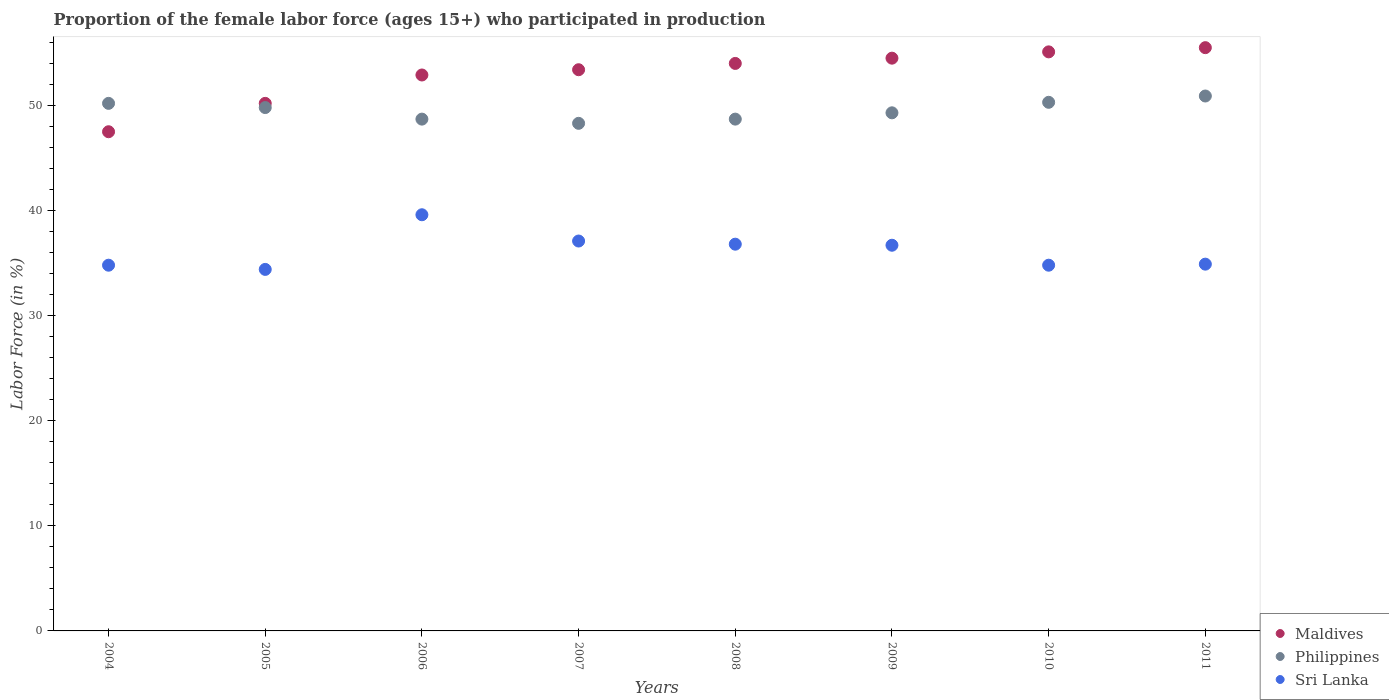How many different coloured dotlines are there?
Provide a short and direct response. 3. What is the proportion of the female labor force who participated in production in Maldives in 2010?
Keep it short and to the point. 55.1. Across all years, what is the maximum proportion of the female labor force who participated in production in Maldives?
Provide a short and direct response. 55.5. Across all years, what is the minimum proportion of the female labor force who participated in production in Maldives?
Provide a succinct answer. 47.5. What is the total proportion of the female labor force who participated in production in Philippines in the graph?
Your response must be concise. 396.2. What is the difference between the proportion of the female labor force who participated in production in Philippines in 2009 and that in 2011?
Offer a terse response. -1.6. What is the difference between the proportion of the female labor force who participated in production in Maldives in 2004 and the proportion of the female labor force who participated in production in Philippines in 2011?
Provide a short and direct response. -3.4. What is the average proportion of the female labor force who participated in production in Sri Lanka per year?
Offer a very short reply. 36.14. In the year 2006, what is the difference between the proportion of the female labor force who participated in production in Sri Lanka and proportion of the female labor force who participated in production in Philippines?
Offer a very short reply. -9.1. In how many years, is the proportion of the female labor force who participated in production in Maldives greater than 24 %?
Provide a short and direct response. 8. What is the ratio of the proportion of the female labor force who participated in production in Philippines in 2004 to that in 2007?
Ensure brevity in your answer.  1.04. Is the proportion of the female labor force who participated in production in Philippines in 2009 less than that in 2011?
Give a very brief answer. Yes. What is the difference between the highest and the second highest proportion of the female labor force who participated in production in Philippines?
Your answer should be very brief. 0.6. What is the difference between the highest and the lowest proportion of the female labor force who participated in production in Maldives?
Ensure brevity in your answer.  8. Is it the case that in every year, the sum of the proportion of the female labor force who participated in production in Philippines and proportion of the female labor force who participated in production in Maldives  is greater than the proportion of the female labor force who participated in production in Sri Lanka?
Make the answer very short. Yes. Does the proportion of the female labor force who participated in production in Philippines monotonically increase over the years?
Provide a short and direct response. No. How many years are there in the graph?
Provide a succinct answer. 8. Are the values on the major ticks of Y-axis written in scientific E-notation?
Provide a short and direct response. No. Does the graph contain any zero values?
Provide a short and direct response. No. How many legend labels are there?
Provide a succinct answer. 3. How are the legend labels stacked?
Give a very brief answer. Vertical. What is the title of the graph?
Give a very brief answer. Proportion of the female labor force (ages 15+) who participated in production. What is the Labor Force (in %) in Maldives in 2004?
Keep it short and to the point. 47.5. What is the Labor Force (in %) in Philippines in 2004?
Offer a very short reply. 50.2. What is the Labor Force (in %) of Sri Lanka in 2004?
Your answer should be compact. 34.8. What is the Labor Force (in %) in Maldives in 2005?
Your response must be concise. 50.2. What is the Labor Force (in %) of Philippines in 2005?
Make the answer very short. 49.8. What is the Labor Force (in %) of Sri Lanka in 2005?
Offer a very short reply. 34.4. What is the Labor Force (in %) of Maldives in 2006?
Keep it short and to the point. 52.9. What is the Labor Force (in %) in Philippines in 2006?
Keep it short and to the point. 48.7. What is the Labor Force (in %) in Sri Lanka in 2006?
Your answer should be compact. 39.6. What is the Labor Force (in %) of Maldives in 2007?
Your answer should be compact. 53.4. What is the Labor Force (in %) in Philippines in 2007?
Your response must be concise. 48.3. What is the Labor Force (in %) of Sri Lanka in 2007?
Your answer should be very brief. 37.1. What is the Labor Force (in %) of Maldives in 2008?
Your answer should be compact. 54. What is the Labor Force (in %) in Philippines in 2008?
Ensure brevity in your answer.  48.7. What is the Labor Force (in %) of Sri Lanka in 2008?
Offer a terse response. 36.8. What is the Labor Force (in %) in Maldives in 2009?
Make the answer very short. 54.5. What is the Labor Force (in %) of Philippines in 2009?
Provide a short and direct response. 49.3. What is the Labor Force (in %) in Sri Lanka in 2009?
Offer a very short reply. 36.7. What is the Labor Force (in %) of Maldives in 2010?
Give a very brief answer. 55.1. What is the Labor Force (in %) of Philippines in 2010?
Provide a short and direct response. 50.3. What is the Labor Force (in %) in Sri Lanka in 2010?
Your answer should be compact. 34.8. What is the Labor Force (in %) in Maldives in 2011?
Offer a very short reply. 55.5. What is the Labor Force (in %) of Philippines in 2011?
Make the answer very short. 50.9. What is the Labor Force (in %) of Sri Lanka in 2011?
Keep it short and to the point. 34.9. Across all years, what is the maximum Labor Force (in %) of Maldives?
Your answer should be compact. 55.5. Across all years, what is the maximum Labor Force (in %) in Philippines?
Give a very brief answer. 50.9. Across all years, what is the maximum Labor Force (in %) in Sri Lanka?
Your response must be concise. 39.6. Across all years, what is the minimum Labor Force (in %) in Maldives?
Keep it short and to the point. 47.5. Across all years, what is the minimum Labor Force (in %) in Philippines?
Your response must be concise. 48.3. Across all years, what is the minimum Labor Force (in %) in Sri Lanka?
Offer a terse response. 34.4. What is the total Labor Force (in %) in Maldives in the graph?
Keep it short and to the point. 423.1. What is the total Labor Force (in %) of Philippines in the graph?
Make the answer very short. 396.2. What is the total Labor Force (in %) of Sri Lanka in the graph?
Provide a short and direct response. 289.1. What is the difference between the Labor Force (in %) of Maldives in 2004 and that in 2005?
Give a very brief answer. -2.7. What is the difference between the Labor Force (in %) of Sri Lanka in 2004 and that in 2005?
Offer a terse response. 0.4. What is the difference between the Labor Force (in %) in Sri Lanka in 2004 and that in 2007?
Make the answer very short. -2.3. What is the difference between the Labor Force (in %) in Maldives in 2004 and that in 2008?
Provide a succinct answer. -6.5. What is the difference between the Labor Force (in %) in Philippines in 2004 and that in 2009?
Keep it short and to the point. 0.9. What is the difference between the Labor Force (in %) of Maldives in 2004 and that in 2010?
Your answer should be very brief. -7.6. What is the difference between the Labor Force (in %) in Philippines in 2004 and that in 2010?
Offer a terse response. -0.1. What is the difference between the Labor Force (in %) in Maldives in 2004 and that in 2011?
Keep it short and to the point. -8. What is the difference between the Labor Force (in %) of Philippines in 2004 and that in 2011?
Ensure brevity in your answer.  -0.7. What is the difference between the Labor Force (in %) in Sri Lanka in 2004 and that in 2011?
Make the answer very short. -0.1. What is the difference between the Labor Force (in %) in Sri Lanka in 2005 and that in 2006?
Ensure brevity in your answer.  -5.2. What is the difference between the Labor Force (in %) in Maldives in 2005 and that in 2007?
Provide a succinct answer. -3.2. What is the difference between the Labor Force (in %) in Philippines in 2005 and that in 2007?
Offer a very short reply. 1.5. What is the difference between the Labor Force (in %) of Philippines in 2005 and that in 2008?
Offer a terse response. 1.1. What is the difference between the Labor Force (in %) in Maldives in 2005 and that in 2009?
Offer a terse response. -4.3. What is the difference between the Labor Force (in %) in Maldives in 2005 and that in 2010?
Provide a short and direct response. -4.9. What is the difference between the Labor Force (in %) in Philippines in 2005 and that in 2010?
Offer a very short reply. -0.5. What is the difference between the Labor Force (in %) of Sri Lanka in 2005 and that in 2010?
Provide a short and direct response. -0.4. What is the difference between the Labor Force (in %) of Maldives in 2005 and that in 2011?
Offer a terse response. -5.3. What is the difference between the Labor Force (in %) in Sri Lanka in 2005 and that in 2011?
Offer a terse response. -0.5. What is the difference between the Labor Force (in %) of Maldives in 2006 and that in 2007?
Give a very brief answer. -0.5. What is the difference between the Labor Force (in %) of Sri Lanka in 2006 and that in 2007?
Keep it short and to the point. 2.5. What is the difference between the Labor Force (in %) in Maldives in 2006 and that in 2009?
Make the answer very short. -1.6. What is the difference between the Labor Force (in %) of Sri Lanka in 2006 and that in 2009?
Your response must be concise. 2.9. What is the difference between the Labor Force (in %) of Maldives in 2006 and that in 2010?
Ensure brevity in your answer.  -2.2. What is the difference between the Labor Force (in %) in Maldives in 2006 and that in 2011?
Provide a short and direct response. -2.6. What is the difference between the Labor Force (in %) in Sri Lanka in 2006 and that in 2011?
Offer a very short reply. 4.7. What is the difference between the Labor Force (in %) of Philippines in 2007 and that in 2008?
Your answer should be compact. -0.4. What is the difference between the Labor Force (in %) of Philippines in 2007 and that in 2009?
Your answer should be very brief. -1. What is the difference between the Labor Force (in %) in Philippines in 2007 and that in 2010?
Your answer should be compact. -2. What is the difference between the Labor Force (in %) in Sri Lanka in 2007 and that in 2010?
Ensure brevity in your answer.  2.3. What is the difference between the Labor Force (in %) in Maldives in 2007 and that in 2011?
Provide a short and direct response. -2.1. What is the difference between the Labor Force (in %) of Philippines in 2007 and that in 2011?
Keep it short and to the point. -2.6. What is the difference between the Labor Force (in %) in Maldives in 2008 and that in 2010?
Your answer should be very brief. -1.1. What is the difference between the Labor Force (in %) of Philippines in 2008 and that in 2010?
Offer a very short reply. -1.6. What is the difference between the Labor Force (in %) of Sri Lanka in 2008 and that in 2010?
Ensure brevity in your answer.  2. What is the difference between the Labor Force (in %) of Maldives in 2009 and that in 2010?
Provide a short and direct response. -0.6. What is the difference between the Labor Force (in %) in Philippines in 2009 and that in 2010?
Offer a very short reply. -1. What is the difference between the Labor Force (in %) in Sri Lanka in 2009 and that in 2010?
Make the answer very short. 1.9. What is the difference between the Labor Force (in %) of Philippines in 2009 and that in 2011?
Ensure brevity in your answer.  -1.6. What is the difference between the Labor Force (in %) of Sri Lanka in 2009 and that in 2011?
Make the answer very short. 1.8. What is the difference between the Labor Force (in %) in Philippines in 2010 and that in 2011?
Provide a short and direct response. -0.6. What is the difference between the Labor Force (in %) of Sri Lanka in 2010 and that in 2011?
Offer a very short reply. -0.1. What is the difference between the Labor Force (in %) in Maldives in 2004 and the Labor Force (in %) in Sri Lanka in 2005?
Keep it short and to the point. 13.1. What is the difference between the Labor Force (in %) in Philippines in 2004 and the Labor Force (in %) in Sri Lanka in 2005?
Keep it short and to the point. 15.8. What is the difference between the Labor Force (in %) in Maldives in 2004 and the Labor Force (in %) in Philippines in 2006?
Provide a short and direct response. -1.2. What is the difference between the Labor Force (in %) of Maldives in 2004 and the Labor Force (in %) of Sri Lanka in 2006?
Give a very brief answer. 7.9. What is the difference between the Labor Force (in %) of Philippines in 2004 and the Labor Force (in %) of Sri Lanka in 2006?
Keep it short and to the point. 10.6. What is the difference between the Labor Force (in %) in Maldives in 2004 and the Labor Force (in %) in Philippines in 2007?
Ensure brevity in your answer.  -0.8. What is the difference between the Labor Force (in %) of Maldives in 2004 and the Labor Force (in %) of Sri Lanka in 2007?
Your response must be concise. 10.4. What is the difference between the Labor Force (in %) of Maldives in 2004 and the Labor Force (in %) of Philippines in 2008?
Provide a succinct answer. -1.2. What is the difference between the Labor Force (in %) of Maldives in 2004 and the Labor Force (in %) of Philippines in 2009?
Offer a terse response. -1.8. What is the difference between the Labor Force (in %) in Maldives in 2004 and the Labor Force (in %) in Sri Lanka in 2009?
Offer a terse response. 10.8. What is the difference between the Labor Force (in %) in Philippines in 2004 and the Labor Force (in %) in Sri Lanka in 2009?
Ensure brevity in your answer.  13.5. What is the difference between the Labor Force (in %) of Philippines in 2004 and the Labor Force (in %) of Sri Lanka in 2010?
Your answer should be very brief. 15.4. What is the difference between the Labor Force (in %) in Maldives in 2004 and the Labor Force (in %) in Philippines in 2011?
Provide a succinct answer. -3.4. What is the difference between the Labor Force (in %) in Maldives in 2004 and the Labor Force (in %) in Sri Lanka in 2011?
Provide a succinct answer. 12.6. What is the difference between the Labor Force (in %) in Philippines in 2004 and the Labor Force (in %) in Sri Lanka in 2011?
Your answer should be compact. 15.3. What is the difference between the Labor Force (in %) in Philippines in 2005 and the Labor Force (in %) in Sri Lanka in 2006?
Provide a succinct answer. 10.2. What is the difference between the Labor Force (in %) of Maldives in 2005 and the Labor Force (in %) of Philippines in 2008?
Offer a terse response. 1.5. What is the difference between the Labor Force (in %) of Philippines in 2005 and the Labor Force (in %) of Sri Lanka in 2009?
Offer a very short reply. 13.1. What is the difference between the Labor Force (in %) of Maldives in 2005 and the Labor Force (in %) of Philippines in 2010?
Provide a short and direct response. -0.1. What is the difference between the Labor Force (in %) of Philippines in 2005 and the Labor Force (in %) of Sri Lanka in 2010?
Your answer should be compact. 15. What is the difference between the Labor Force (in %) of Maldives in 2005 and the Labor Force (in %) of Philippines in 2011?
Give a very brief answer. -0.7. What is the difference between the Labor Force (in %) of Maldives in 2005 and the Labor Force (in %) of Sri Lanka in 2011?
Keep it short and to the point. 15.3. What is the difference between the Labor Force (in %) in Maldives in 2006 and the Labor Force (in %) in Philippines in 2007?
Your answer should be compact. 4.6. What is the difference between the Labor Force (in %) of Maldives in 2006 and the Labor Force (in %) of Sri Lanka in 2007?
Offer a terse response. 15.8. What is the difference between the Labor Force (in %) in Philippines in 2006 and the Labor Force (in %) in Sri Lanka in 2007?
Offer a very short reply. 11.6. What is the difference between the Labor Force (in %) in Maldives in 2006 and the Labor Force (in %) in Sri Lanka in 2008?
Keep it short and to the point. 16.1. What is the difference between the Labor Force (in %) of Maldives in 2006 and the Labor Force (in %) of Philippines in 2009?
Provide a short and direct response. 3.6. What is the difference between the Labor Force (in %) in Maldives in 2006 and the Labor Force (in %) in Philippines in 2011?
Your answer should be very brief. 2. What is the difference between the Labor Force (in %) of Maldives in 2007 and the Labor Force (in %) of Philippines in 2008?
Your response must be concise. 4.7. What is the difference between the Labor Force (in %) of Philippines in 2007 and the Labor Force (in %) of Sri Lanka in 2008?
Keep it short and to the point. 11.5. What is the difference between the Labor Force (in %) in Philippines in 2007 and the Labor Force (in %) in Sri Lanka in 2009?
Ensure brevity in your answer.  11.6. What is the difference between the Labor Force (in %) of Maldives in 2007 and the Labor Force (in %) of Sri Lanka in 2010?
Provide a short and direct response. 18.6. What is the difference between the Labor Force (in %) in Maldives in 2007 and the Labor Force (in %) in Philippines in 2011?
Keep it short and to the point. 2.5. What is the difference between the Labor Force (in %) of Maldives in 2007 and the Labor Force (in %) of Sri Lanka in 2011?
Offer a very short reply. 18.5. What is the difference between the Labor Force (in %) of Maldives in 2008 and the Labor Force (in %) of Sri Lanka in 2009?
Your response must be concise. 17.3. What is the difference between the Labor Force (in %) in Philippines in 2008 and the Labor Force (in %) in Sri Lanka in 2009?
Offer a terse response. 12. What is the difference between the Labor Force (in %) of Maldives in 2008 and the Labor Force (in %) of Sri Lanka in 2010?
Your answer should be very brief. 19.2. What is the difference between the Labor Force (in %) of Philippines in 2008 and the Labor Force (in %) of Sri Lanka in 2010?
Keep it short and to the point. 13.9. What is the difference between the Labor Force (in %) of Maldives in 2008 and the Labor Force (in %) of Philippines in 2011?
Keep it short and to the point. 3.1. What is the difference between the Labor Force (in %) in Maldives in 2009 and the Labor Force (in %) in Philippines in 2010?
Make the answer very short. 4.2. What is the difference between the Labor Force (in %) in Maldives in 2009 and the Labor Force (in %) in Sri Lanka in 2011?
Ensure brevity in your answer.  19.6. What is the difference between the Labor Force (in %) of Philippines in 2009 and the Labor Force (in %) of Sri Lanka in 2011?
Ensure brevity in your answer.  14.4. What is the difference between the Labor Force (in %) in Maldives in 2010 and the Labor Force (in %) in Philippines in 2011?
Keep it short and to the point. 4.2. What is the difference between the Labor Force (in %) in Maldives in 2010 and the Labor Force (in %) in Sri Lanka in 2011?
Your answer should be compact. 20.2. What is the average Labor Force (in %) of Maldives per year?
Make the answer very short. 52.89. What is the average Labor Force (in %) of Philippines per year?
Offer a terse response. 49.52. What is the average Labor Force (in %) in Sri Lanka per year?
Provide a short and direct response. 36.14. In the year 2004, what is the difference between the Labor Force (in %) of Maldives and Labor Force (in %) of Sri Lanka?
Offer a terse response. 12.7. In the year 2005, what is the difference between the Labor Force (in %) of Maldives and Labor Force (in %) of Philippines?
Provide a short and direct response. 0.4. In the year 2005, what is the difference between the Labor Force (in %) of Philippines and Labor Force (in %) of Sri Lanka?
Your answer should be very brief. 15.4. In the year 2006, what is the difference between the Labor Force (in %) in Maldives and Labor Force (in %) in Philippines?
Offer a terse response. 4.2. In the year 2006, what is the difference between the Labor Force (in %) in Maldives and Labor Force (in %) in Sri Lanka?
Provide a short and direct response. 13.3. In the year 2006, what is the difference between the Labor Force (in %) in Philippines and Labor Force (in %) in Sri Lanka?
Ensure brevity in your answer.  9.1. In the year 2007, what is the difference between the Labor Force (in %) of Maldives and Labor Force (in %) of Philippines?
Provide a short and direct response. 5.1. In the year 2008, what is the difference between the Labor Force (in %) in Maldives and Labor Force (in %) in Philippines?
Give a very brief answer. 5.3. In the year 2008, what is the difference between the Labor Force (in %) of Maldives and Labor Force (in %) of Sri Lanka?
Make the answer very short. 17.2. In the year 2009, what is the difference between the Labor Force (in %) in Maldives and Labor Force (in %) in Philippines?
Keep it short and to the point. 5.2. In the year 2009, what is the difference between the Labor Force (in %) of Maldives and Labor Force (in %) of Sri Lanka?
Provide a short and direct response. 17.8. In the year 2009, what is the difference between the Labor Force (in %) of Philippines and Labor Force (in %) of Sri Lanka?
Keep it short and to the point. 12.6. In the year 2010, what is the difference between the Labor Force (in %) in Maldives and Labor Force (in %) in Sri Lanka?
Your answer should be compact. 20.3. In the year 2011, what is the difference between the Labor Force (in %) of Maldives and Labor Force (in %) of Philippines?
Provide a short and direct response. 4.6. In the year 2011, what is the difference between the Labor Force (in %) of Maldives and Labor Force (in %) of Sri Lanka?
Make the answer very short. 20.6. What is the ratio of the Labor Force (in %) of Maldives in 2004 to that in 2005?
Give a very brief answer. 0.95. What is the ratio of the Labor Force (in %) of Philippines in 2004 to that in 2005?
Offer a very short reply. 1.01. What is the ratio of the Labor Force (in %) of Sri Lanka in 2004 to that in 2005?
Offer a terse response. 1.01. What is the ratio of the Labor Force (in %) in Maldives in 2004 to that in 2006?
Offer a terse response. 0.9. What is the ratio of the Labor Force (in %) in Philippines in 2004 to that in 2006?
Make the answer very short. 1.03. What is the ratio of the Labor Force (in %) of Sri Lanka in 2004 to that in 2006?
Your answer should be compact. 0.88. What is the ratio of the Labor Force (in %) in Maldives in 2004 to that in 2007?
Keep it short and to the point. 0.89. What is the ratio of the Labor Force (in %) of Philippines in 2004 to that in 2007?
Ensure brevity in your answer.  1.04. What is the ratio of the Labor Force (in %) of Sri Lanka in 2004 to that in 2007?
Keep it short and to the point. 0.94. What is the ratio of the Labor Force (in %) of Maldives in 2004 to that in 2008?
Your response must be concise. 0.88. What is the ratio of the Labor Force (in %) of Philippines in 2004 to that in 2008?
Your response must be concise. 1.03. What is the ratio of the Labor Force (in %) in Sri Lanka in 2004 to that in 2008?
Offer a terse response. 0.95. What is the ratio of the Labor Force (in %) of Maldives in 2004 to that in 2009?
Your answer should be very brief. 0.87. What is the ratio of the Labor Force (in %) in Philippines in 2004 to that in 2009?
Your answer should be very brief. 1.02. What is the ratio of the Labor Force (in %) in Sri Lanka in 2004 to that in 2009?
Provide a succinct answer. 0.95. What is the ratio of the Labor Force (in %) in Maldives in 2004 to that in 2010?
Provide a short and direct response. 0.86. What is the ratio of the Labor Force (in %) of Maldives in 2004 to that in 2011?
Make the answer very short. 0.86. What is the ratio of the Labor Force (in %) in Philippines in 2004 to that in 2011?
Your answer should be compact. 0.99. What is the ratio of the Labor Force (in %) in Sri Lanka in 2004 to that in 2011?
Keep it short and to the point. 1. What is the ratio of the Labor Force (in %) of Maldives in 2005 to that in 2006?
Your answer should be very brief. 0.95. What is the ratio of the Labor Force (in %) in Philippines in 2005 to that in 2006?
Your answer should be compact. 1.02. What is the ratio of the Labor Force (in %) of Sri Lanka in 2005 to that in 2006?
Offer a very short reply. 0.87. What is the ratio of the Labor Force (in %) of Maldives in 2005 to that in 2007?
Your response must be concise. 0.94. What is the ratio of the Labor Force (in %) in Philippines in 2005 to that in 2007?
Give a very brief answer. 1.03. What is the ratio of the Labor Force (in %) in Sri Lanka in 2005 to that in 2007?
Provide a short and direct response. 0.93. What is the ratio of the Labor Force (in %) of Maldives in 2005 to that in 2008?
Keep it short and to the point. 0.93. What is the ratio of the Labor Force (in %) of Philippines in 2005 to that in 2008?
Your answer should be very brief. 1.02. What is the ratio of the Labor Force (in %) in Sri Lanka in 2005 to that in 2008?
Give a very brief answer. 0.93. What is the ratio of the Labor Force (in %) in Maldives in 2005 to that in 2009?
Offer a terse response. 0.92. What is the ratio of the Labor Force (in %) of Sri Lanka in 2005 to that in 2009?
Your answer should be compact. 0.94. What is the ratio of the Labor Force (in %) in Maldives in 2005 to that in 2010?
Your response must be concise. 0.91. What is the ratio of the Labor Force (in %) of Sri Lanka in 2005 to that in 2010?
Your answer should be very brief. 0.99. What is the ratio of the Labor Force (in %) of Maldives in 2005 to that in 2011?
Make the answer very short. 0.9. What is the ratio of the Labor Force (in %) of Philippines in 2005 to that in 2011?
Offer a very short reply. 0.98. What is the ratio of the Labor Force (in %) of Sri Lanka in 2005 to that in 2011?
Provide a succinct answer. 0.99. What is the ratio of the Labor Force (in %) of Maldives in 2006 to that in 2007?
Provide a succinct answer. 0.99. What is the ratio of the Labor Force (in %) of Philippines in 2006 to that in 2007?
Give a very brief answer. 1.01. What is the ratio of the Labor Force (in %) in Sri Lanka in 2006 to that in 2007?
Offer a terse response. 1.07. What is the ratio of the Labor Force (in %) in Maldives in 2006 to that in 2008?
Your answer should be compact. 0.98. What is the ratio of the Labor Force (in %) of Philippines in 2006 to that in 2008?
Ensure brevity in your answer.  1. What is the ratio of the Labor Force (in %) in Sri Lanka in 2006 to that in 2008?
Give a very brief answer. 1.08. What is the ratio of the Labor Force (in %) of Maldives in 2006 to that in 2009?
Make the answer very short. 0.97. What is the ratio of the Labor Force (in %) in Philippines in 2006 to that in 2009?
Give a very brief answer. 0.99. What is the ratio of the Labor Force (in %) in Sri Lanka in 2006 to that in 2009?
Your response must be concise. 1.08. What is the ratio of the Labor Force (in %) in Maldives in 2006 to that in 2010?
Make the answer very short. 0.96. What is the ratio of the Labor Force (in %) of Philippines in 2006 to that in 2010?
Make the answer very short. 0.97. What is the ratio of the Labor Force (in %) of Sri Lanka in 2006 to that in 2010?
Ensure brevity in your answer.  1.14. What is the ratio of the Labor Force (in %) in Maldives in 2006 to that in 2011?
Make the answer very short. 0.95. What is the ratio of the Labor Force (in %) of Philippines in 2006 to that in 2011?
Your answer should be compact. 0.96. What is the ratio of the Labor Force (in %) of Sri Lanka in 2006 to that in 2011?
Your answer should be very brief. 1.13. What is the ratio of the Labor Force (in %) of Maldives in 2007 to that in 2008?
Offer a very short reply. 0.99. What is the ratio of the Labor Force (in %) of Sri Lanka in 2007 to that in 2008?
Make the answer very short. 1.01. What is the ratio of the Labor Force (in %) in Maldives in 2007 to that in 2009?
Provide a short and direct response. 0.98. What is the ratio of the Labor Force (in %) of Philippines in 2007 to that in 2009?
Your response must be concise. 0.98. What is the ratio of the Labor Force (in %) in Sri Lanka in 2007 to that in 2009?
Give a very brief answer. 1.01. What is the ratio of the Labor Force (in %) of Maldives in 2007 to that in 2010?
Offer a very short reply. 0.97. What is the ratio of the Labor Force (in %) of Philippines in 2007 to that in 2010?
Make the answer very short. 0.96. What is the ratio of the Labor Force (in %) in Sri Lanka in 2007 to that in 2010?
Give a very brief answer. 1.07. What is the ratio of the Labor Force (in %) of Maldives in 2007 to that in 2011?
Keep it short and to the point. 0.96. What is the ratio of the Labor Force (in %) in Philippines in 2007 to that in 2011?
Offer a very short reply. 0.95. What is the ratio of the Labor Force (in %) in Sri Lanka in 2007 to that in 2011?
Your answer should be compact. 1.06. What is the ratio of the Labor Force (in %) of Maldives in 2008 to that in 2009?
Make the answer very short. 0.99. What is the ratio of the Labor Force (in %) in Philippines in 2008 to that in 2009?
Your response must be concise. 0.99. What is the ratio of the Labor Force (in %) in Sri Lanka in 2008 to that in 2009?
Make the answer very short. 1. What is the ratio of the Labor Force (in %) in Philippines in 2008 to that in 2010?
Your answer should be compact. 0.97. What is the ratio of the Labor Force (in %) of Sri Lanka in 2008 to that in 2010?
Give a very brief answer. 1.06. What is the ratio of the Labor Force (in %) in Philippines in 2008 to that in 2011?
Offer a terse response. 0.96. What is the ratio of the Labor Force (in %) of Sri Lanka in 2008 to that in 2011?
Offer a very short reply. 1.05. What is the ratio of the Labor Force (in %) in Maldives in 2009 to that in 2010?
Keep it short and to the point. 0.99. What is the ratio of the Labor Force (in %) in Philippines in 2009 to that in 2010?
Ensure brevity in your answer.  0.98. What is the ratio of the Labor Force (in %) of Sri Lanka in 2009 to that in 2010?
Keep it short and to the point. 1.05. What is the ratio of the Labor Force (in %) of Maldives in 2009 to that in 2011?
Keep it short and to the point. 0.98. What is the ratio of the Labor Force (in %) of Philippines in 2009 to that in 2011?
Provide a succinct answer. 0.97. What is the ratio of the Labor Force (in %) in Sri Lanka in 2009 to that in 2011?
Your answer should be very brief. 1.05. What is the ratio of the Labor Force (in %) in Philippines in 2010 to that in 2011?
Your response must be concise. 0.99. What is the difference between the highest and the second highest Labor Force (in %) in Sri Lanka?
Offer a terse response. 2.5. What is the difference between the highest and the lowest Labor Force (in %) of Maldives?
Your answer should be very brief. 8. 